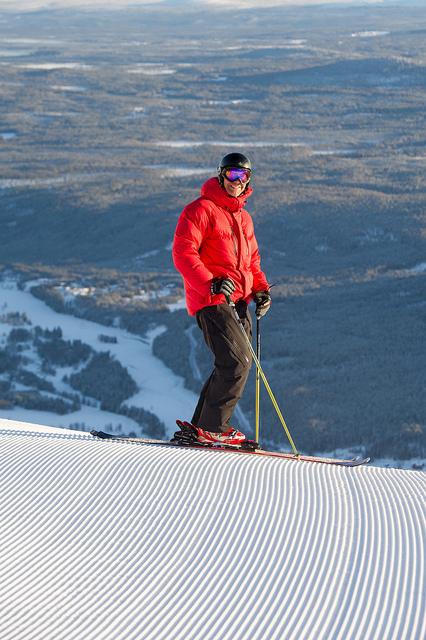What is on the man's hands?
Write a very short answer. Gloves. Is the man in the foreground at a higher elevation than the background?
Write a very short answer. Yes. What color is the man's jacket?
Be succinct. Red. 